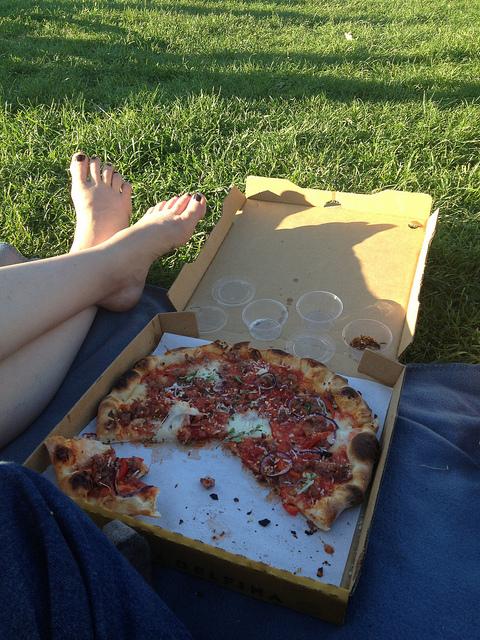Has any of the pizza been removed?
Give a very brief answer. Yes. Do you expect more people to eat the pizza?
Be succinct. Yes. What color is the blanket?
Short answer required. Blue. What type of crust is the pizza?
Write a very short answer. Thick. 